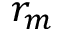Convert formula to latex. <formula><loc_0><loc_0><loc_500><loc_500>r _ { m }</formula> 